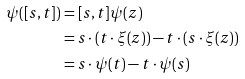<formula> <loc_0><loc_0><loc_500><loc_500>\psi ( [ s , t ] ) & = [ s , t ] \psi ( z ) \\ & = s \cdot ( t \cdot \xi ( z ) ) - t \cdot ( s \cdot \xi ( z ) ) \\ & = s \cdot \psi ( t ) - t \cdot \psi ( s )</formula> 